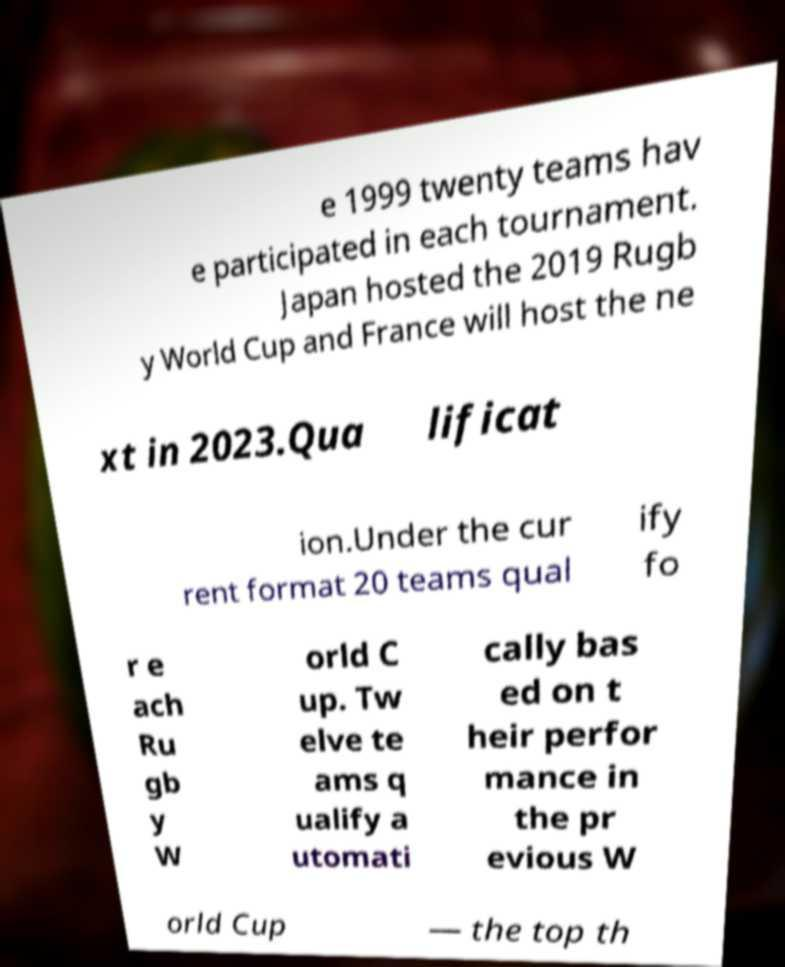What messages or text are displayed in this image? I need them in a readable, typed format. e 1999 twenty teams hav e participated in each tournament. Japan hosted the 2019 Rugb y World Cup and France will host the ne xt in 2023.Qua lificat ion.Under the cur rent format 20 teams qual ify fo r e ach Ru gb y W orld C up. Tw elve te ams q ualify a utomati cally bas ed on t heir perfor mance in the pr evious W orld Cup — the top th 